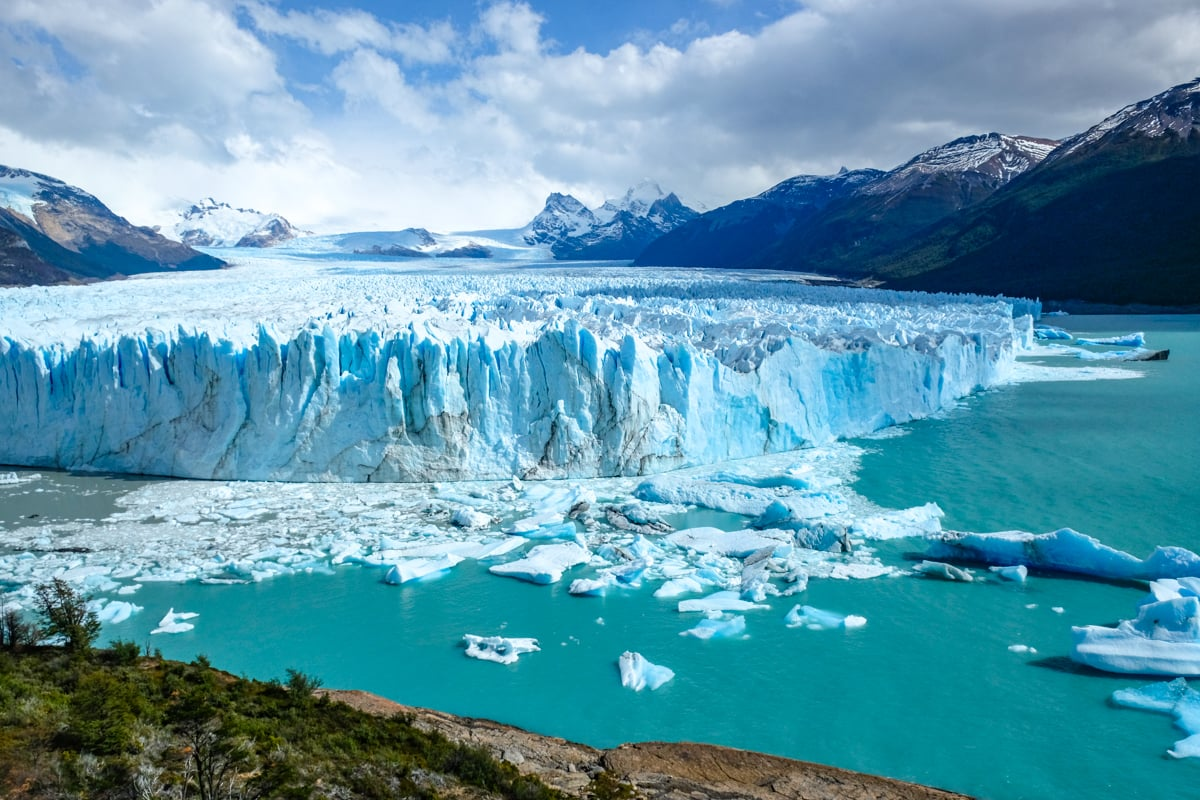Create a short, realistic scenario where a family is visiting the glacier. As the family steps off the viewing platform, they are immediately taken aback by the sheer size and beauty of the Perito Moreno Glacier. The children run ahead, eager to get a closer look at the massive ice sheets and the playful blue icebergs dotting the water below. The parents, holding hands, pause to take in the breathtaking scenery, snapping photos and sharing the awe of this natural wonder. They listen to the rumbling sound of ice calving—a sound both thrilling and humbling. The family bonds over the shared experience, finding joy in the majestic and pristine environment surrounding them.  Now, can you write an extended realistic scenario involving a research team studying the glacier? A research team, composed of glaciologists and climate scientists, arrives at the Perito Moreno Glacier early in the morning, when the first light of dawn still casts a golden hue on the glacier's surface. Their mission is to study the glacier’s dynamics and the impact of climate change. Carrying sophisticated instruments and wearing protective gear, the team sets up a temporary base near the glacier's edge. They drill into the ice to collect core sharegpt4v/samples, which will provide valuable data on the glacier's age and the historical climate patterns encapsulated within its frozen layers. One of the scientists sets up drones to capture aerial footage, providing real-time data on the glacier's current state and any recent changes. Despite the harsh and cold conditions, the team works tirelessly, driven by their shared passion for understanding and preserving this natural wonder. As they take notes and discuss their findings, they can't help but feel a deep sense of responsibility in documenting the vital stories the glacier holds—stories that could inform future climate action. After a long day of meticulous research, the team gathers to review the data, ensuring that their work could help in global efforts to combat climate change.  If the sky in the image could transform into a dynamic canvas depicting the glacier's history, what might it show? If the sky above the glacier transformed into a dynamic canvas portraying the glacier's history, it might present an epic visual narrative spanning thousands of years. The canvas would show the birth of the glacier during the last Ice Age, with colossal ice sheets forming and gradually advancing. The sequence would then capture centuries of slow, forceful movement, carving out valleys and shaping the rugged landscape. The animation could depict the arrival of ancient flora and fauna, followed by the migration of early human tribes, showing how they adapted to the icy environment. Fast forward to the modern era, visuals might illustrate the arrival of European explorers, the establishment of nearby settlements, and the growth of El Calafate as a tourist destination. Dramatic representations of climatic shifts would be highlighted, portraying periods of significant melting and reformation. In a poignant climax, the canvas might show the present-day reality of climate change, emphasizing the importance of conservation efforts to preserve this magnificent glacier for future generations. Throughout the display, the vibrant hues of the sky could interactively change, reflecting the mood and era of each historical period, creating an immersive and educational experience for the viewer. 